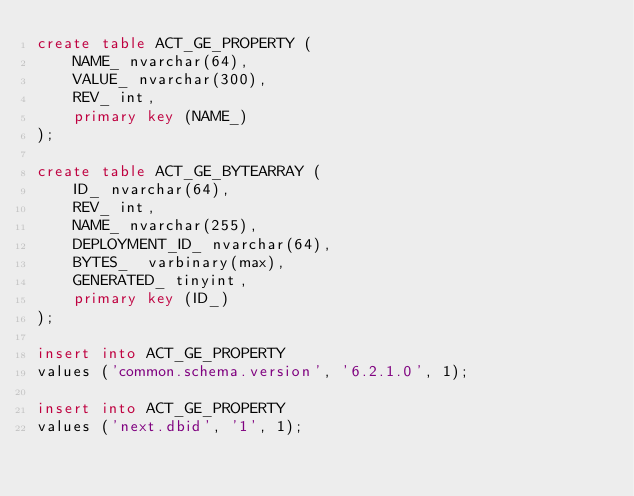Convert code to text. <code><loc_0><loc_0><loc_500><loc_500><_SQL_>create table ACT_GE_PROPERTY (
    NAME_ nvarchar(64),
    VALUE_ nvarchar(300),
    REV_ int,
    primary key (NAME_)
);

create table ACT_GE_BYTEARRAY (
    ID_ nvarchar(64),
    REV_ int,
    NAME_ nvarchar(255),
    DEPLOYMENT_ID_ nvarchar(64),
    BYTES_  varbinary(max),
    GENERATED_ tinyint,
    primary key (ID_)
);

insert into ACT_GE_PROPERTY
values ('common.schema.version', '6.2.1.0', 1);

insert into ACT_GE_PROPERTY
values ('next.dbid', '1', 1);
</code> 